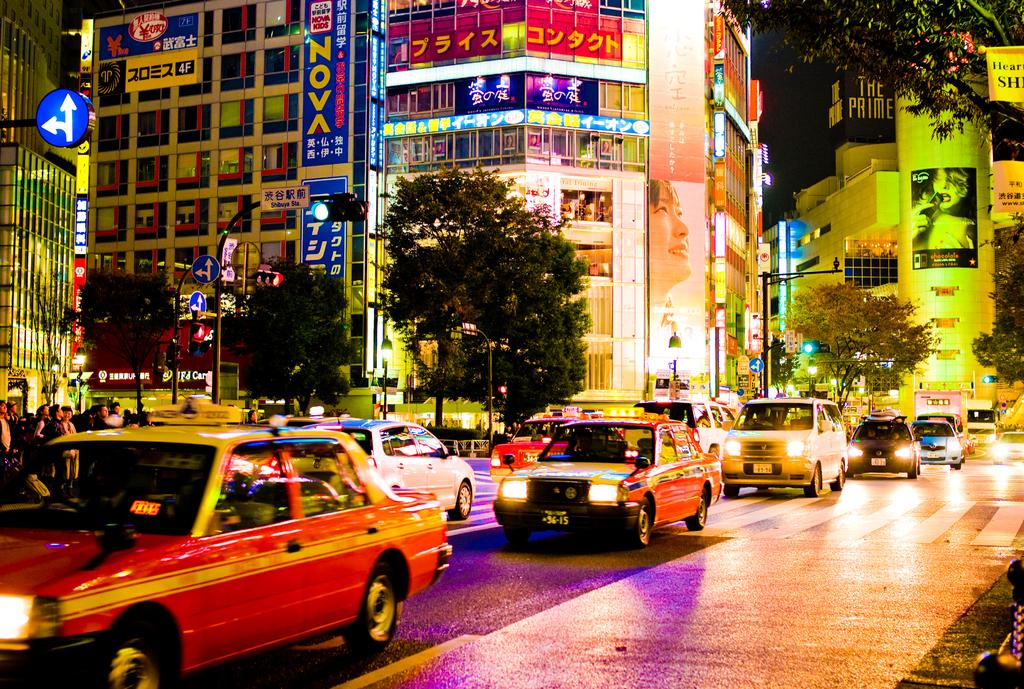<image>
Describe the image concisely. A city street scene with a building called The Prime in the back left. 